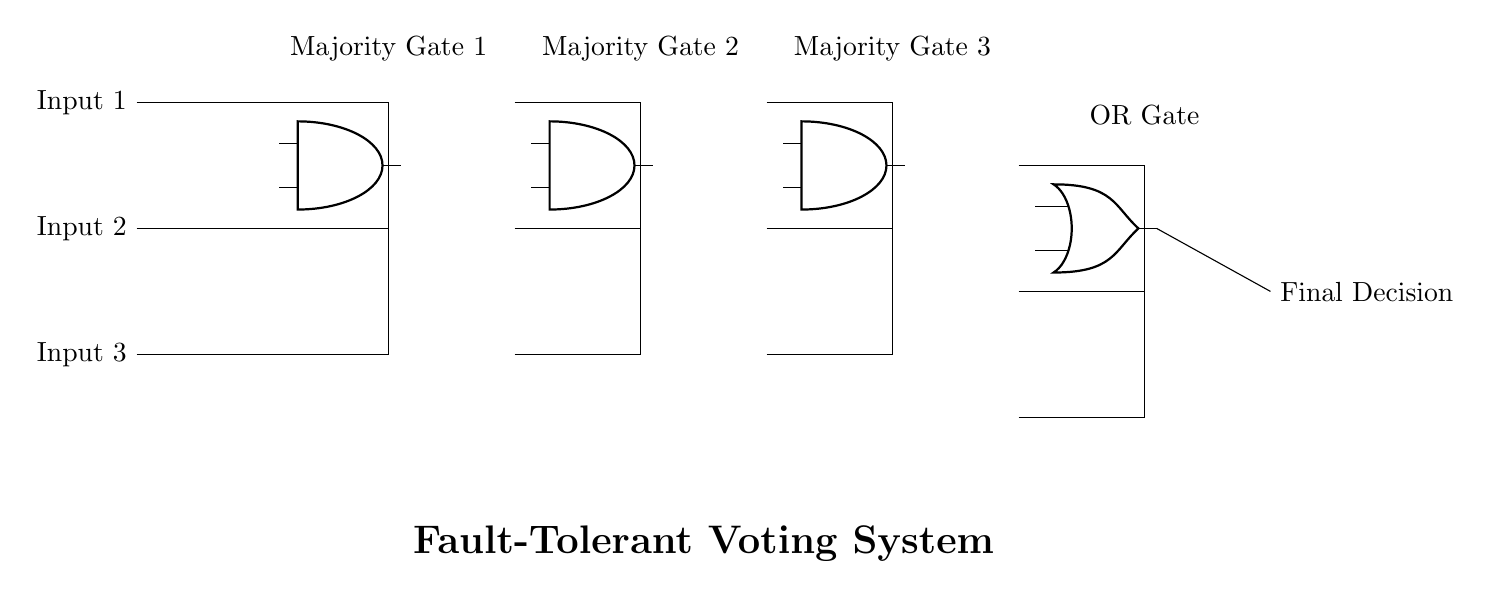What is the type of gates used in this circuit? The circuit predominantly uses majority gates and one OR gate, as indicated by the labels and structure within the diagram.
Answer: majority and OR How many inputs does each majority gate take? Each majority gate in the circuit architecture receives three input signals, evident from the three wires feeding into each gate.
Answer: three What is the output of the entire voting system called? The final output of the voting system is labeled as "Final Decision" in the circuit diagram, which conveys the result after processing through the gates.
Answer: Final Decision How many majority gates are present in the circuit? The diagram includes three distinct majority gates, each labeled and positioned in a sequential manner on the left side of the OR gate.
Answer: three What logical operation does the OR gate perform in this context? In the context of this circuit, the OR gate combines the outputs of the majority gates and returns true if at least one of them is true, which is essential in voting systems for decision-making.
Answer: combines outputs What is the purpose of using majority gates in this system? Majority gates enhance fault tolerance by ensuring that the output reflects the majority opinion among the inputs, reducing the impact of any faulty or incorrect input signals during decision-making.
Answer: enhance fault tolerance Which component connects the majority gates to the final output? The final output is connected to the majority gates through an OR gate, which consolidates their outputs into a single signal labeled "Final Decision."
Answer: OR gate 